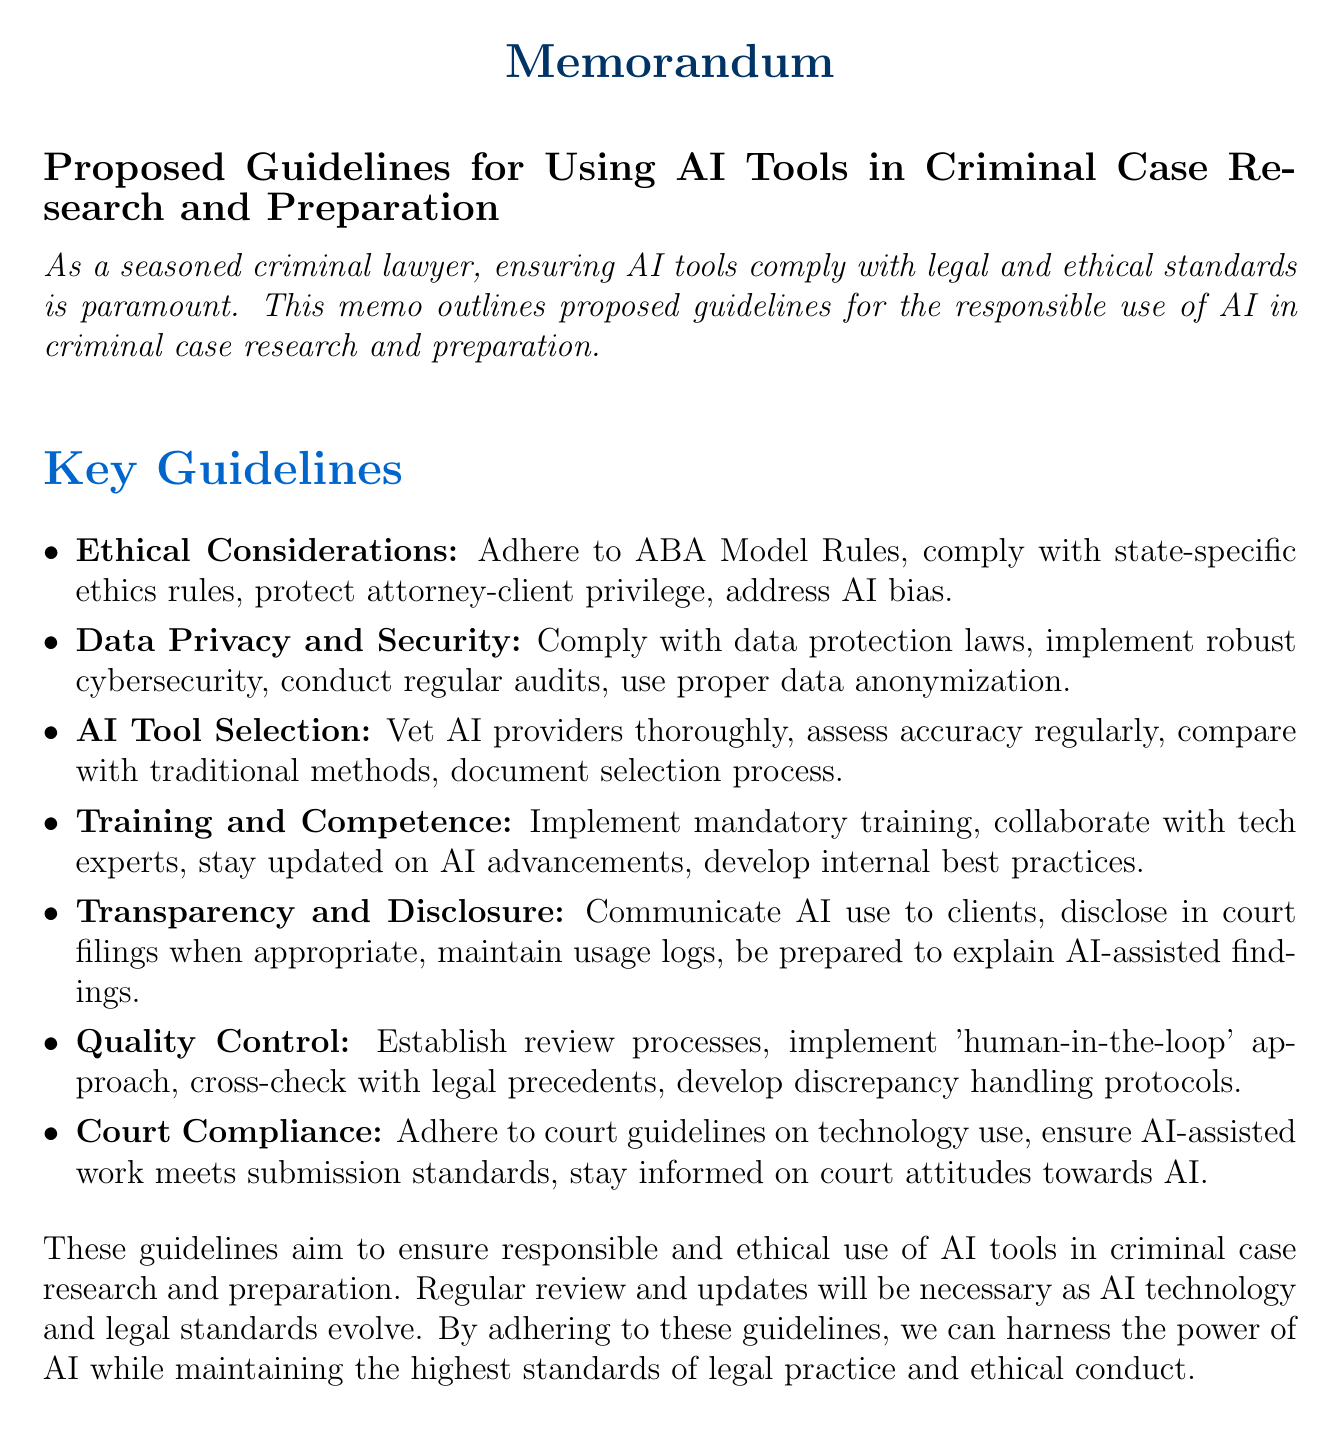What is the main purpose of the memo? The purpose of the memo is to outline proposed guidelines for the responsible use of AI in criminal case research and preparation.
Answer: outline proposed guidelines for the responsible use of AI in criminal case research and preparation Which ethical principle regarding confidentiality is mentioned? The document mentions adherence to Rule 1.6 (Confidentiality of Information) from the ABA Model Rules of Professional Conduct.
Answer: Rule 1.6 (Confidentiality of Information) What do the proposed guidelines aim to ensure? The proposed guidelines aim to ensure responsible and ethical use of AI tools in criminal case research and preparation.
Answer: responsible and ethical use of AI tools in criminal case research and preparation How often should security audits of AI tools be conducted? The document states that regular security audits of AI tools should be performed.
Answer: regular What is a key element of the 'Quality Control and Human Oversight' section? A key element is the establishment of a review process for AI-generated research and analysis.
Answer: establishment of a review process for AI-generated research and analysis What type of training is mandated for attorneys and staff? The memo requires mandatory training programs for attorneys and staff on AI tool usage.
Answer: mandatory training programs Which court guidelines must be adhered to according to the proposal? The memo specifies adherence to specific court guidelines on technology use, such as those set by the U.S. Court of Appeals for the Federal Circuit.
Answer: specific court guidelines on technology use What is expected to be documented during the AI tool selection process? The document states that documentation of the AI tool selection process and rationale is expected.
Answer: documentation of AI tool selection process and rationale 